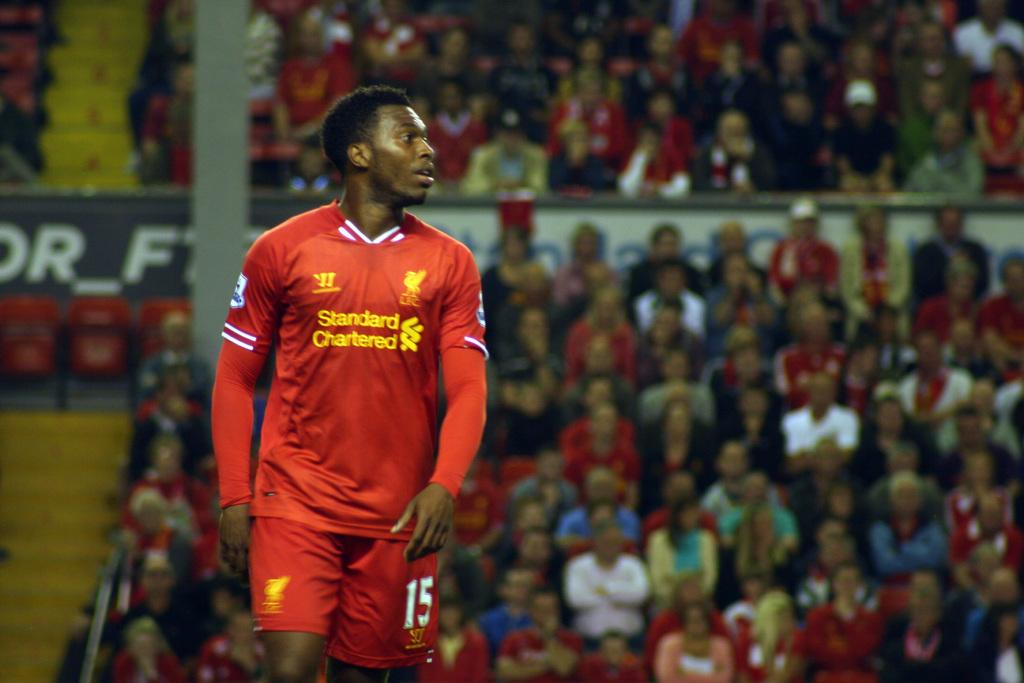<image>
Offer a succinct explanation of the picture presented. A soccer player is wearing a jersey that says Standard Chartered 